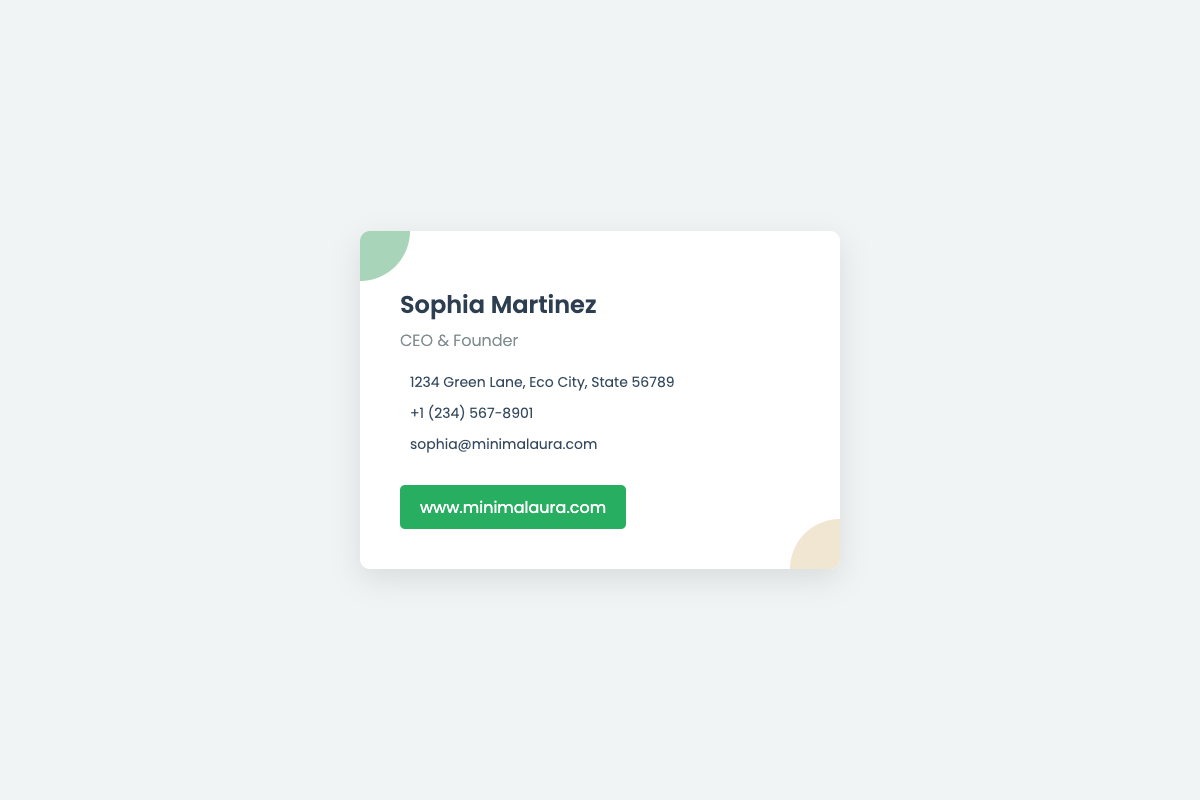What is the owner's name? The owner's name is displayed prominently at the top of the card.
Answer: Sophia Martinez What is the title of the owner? The title of the owner follows the name and indicates their position in the company.
Answer: CEO & Founder What is the business address? The business address is provided in a specific format indicating the location of the company.
Answer: 1234 Green Lane, Eco City, State 56789 What is the phone number? The phone number is listed with a specific country code for ease of communication.
Answer: +1 (234) 567-8901 What is the email address? The email address is included to allow for direct contact with the owner.
Answer: sophia@minimalaura.com What is the website URL? The website URL is provided at the bottom and is clickable for easy access.
Answer: www.minimalaura.com How many sections are in the card? The card contains several distinct sections including name, title, contact information, and website.
Answer: Four What design style does the card reflect? The overall aesthetics and layout of the card show a clean and minimalist design approach.
Answer: Minimalist What color scheme is used in the card? The colors of the card create a soothing atmosphere with earth tones and highlights.
Answer: Green and white What information is conveyed in the company title? The company title includes a description of the owner's position and the company's nature.
Answer: CEO & Founder 